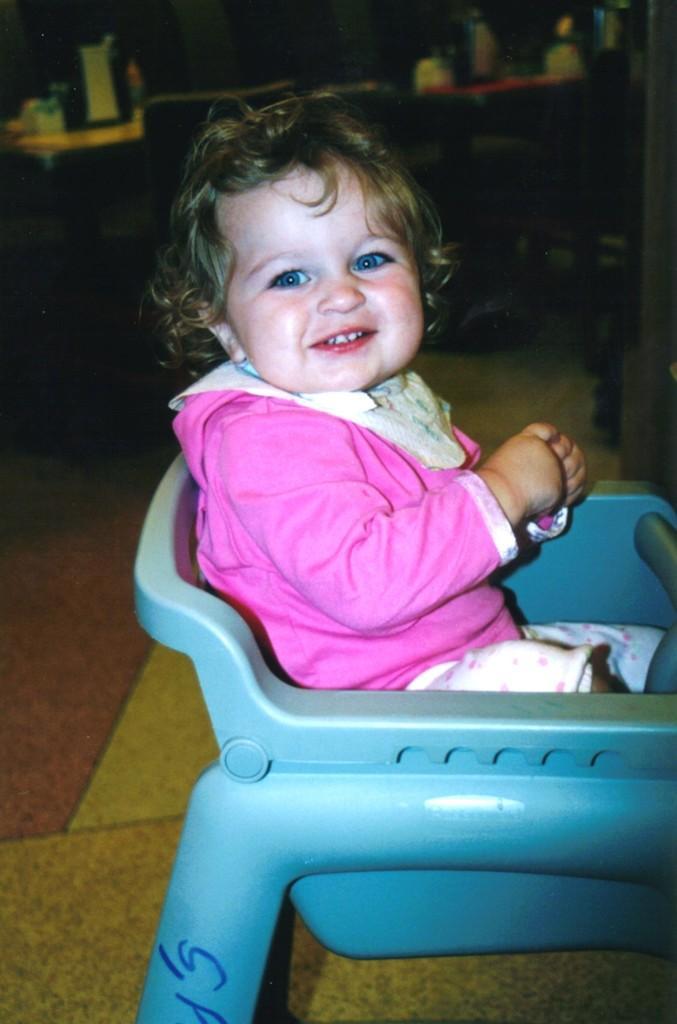In one or two sentences, can you explain what this image depicts? This picture shows a baby sitting in a chair, wearing a pink shirt. In the background there is a table and some chairs here. 